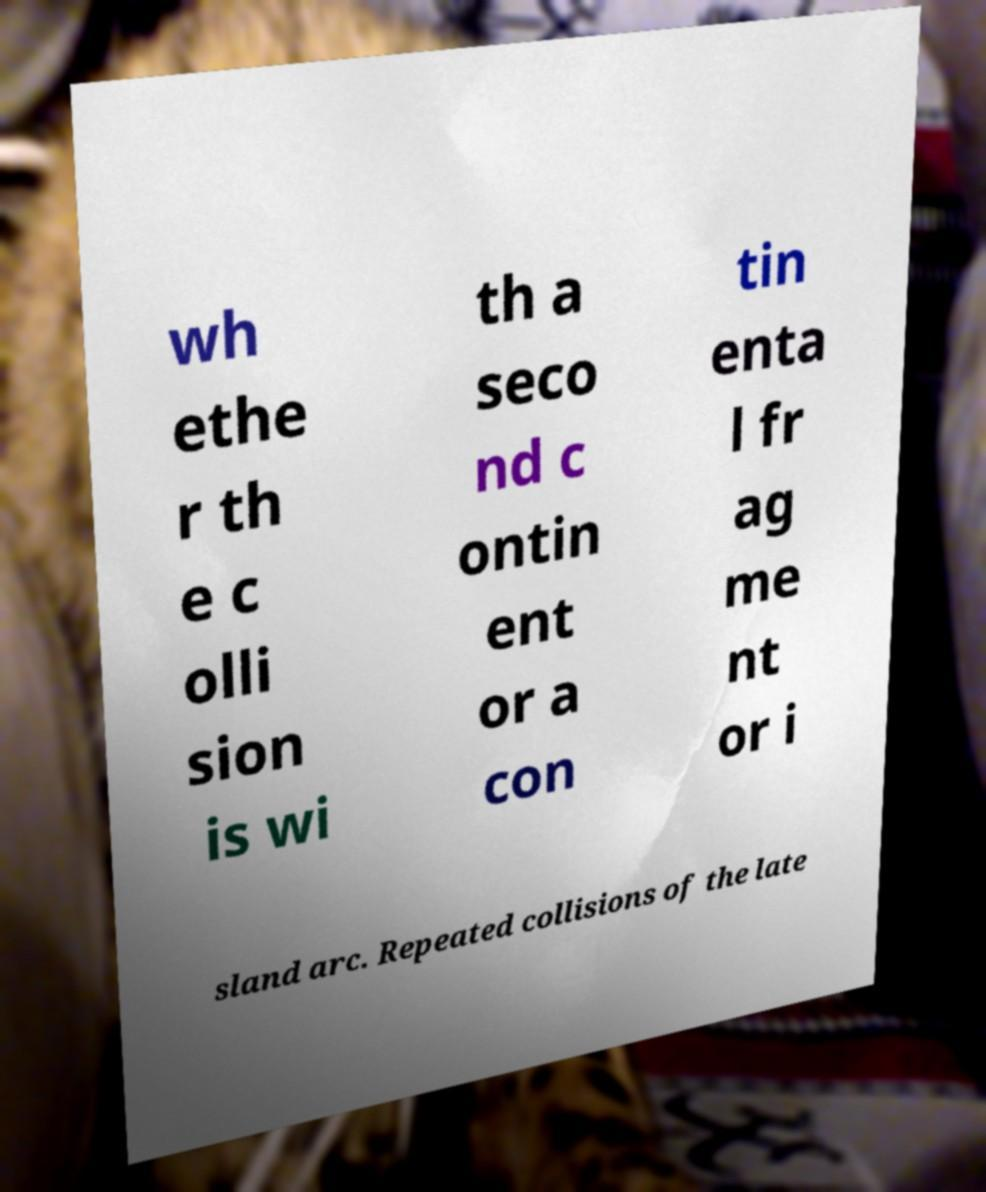Please identify and transcribe the text found in this image. wh ethe r th e c olli sion is wi th a seco nd c ontin ent or a con tin enta l fr ag me nt or i sland arc. Repeated collisions of the late 